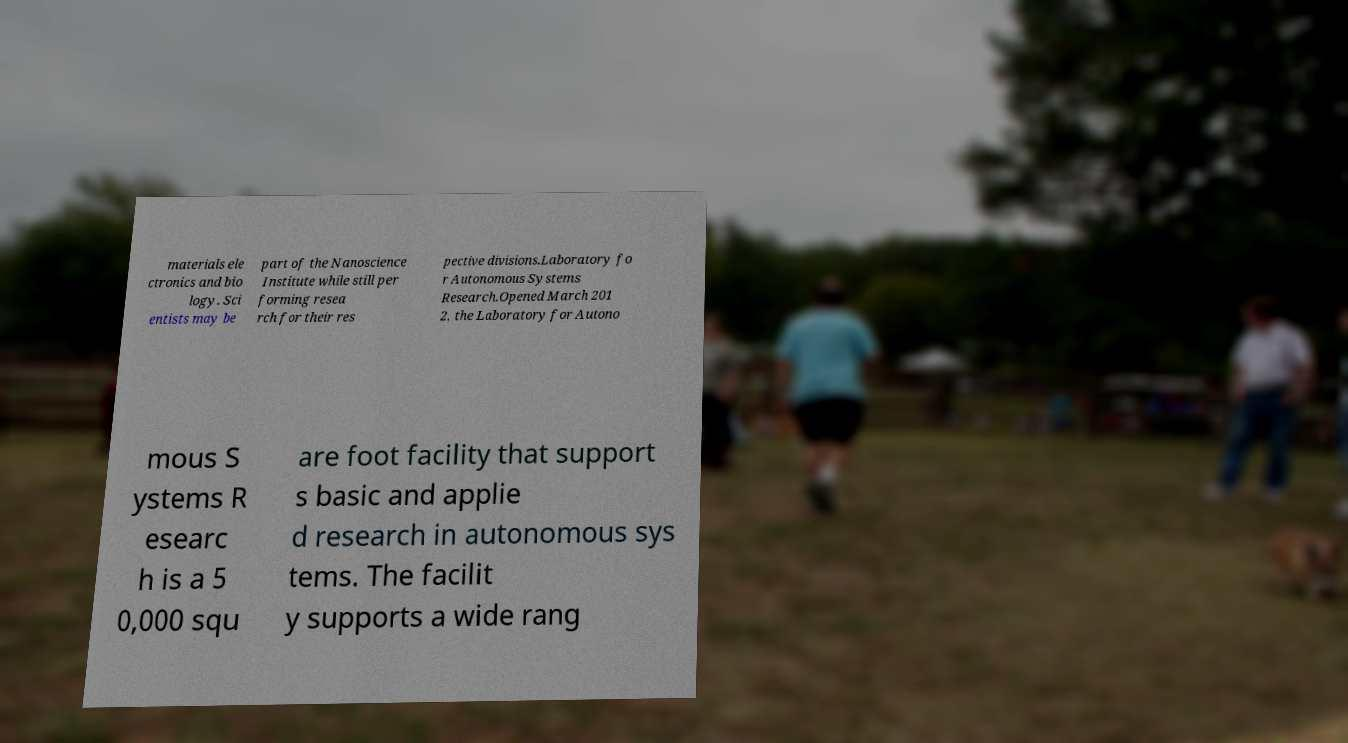Please read and relay the text visible in this image. What does it say? materials ele ctronics and bio logy. Sci entists may be part of the Nanoscience Institute while still per forming resea rch for their res pective divisions.Laboratory fo r Autonomous Systems Research.Opened March 201 2, the Laboratory for Autono mous S ystems R esearc h is a 5 0,000 squ are foot facility that support s basic and applie d research in autonomous sys tems. The facilit y supports a wide rang 